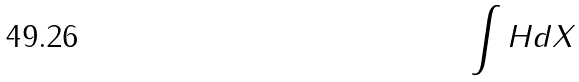<formula> <loc_0><loc_0><loc_500><loc_500>\int H d X</formula> 